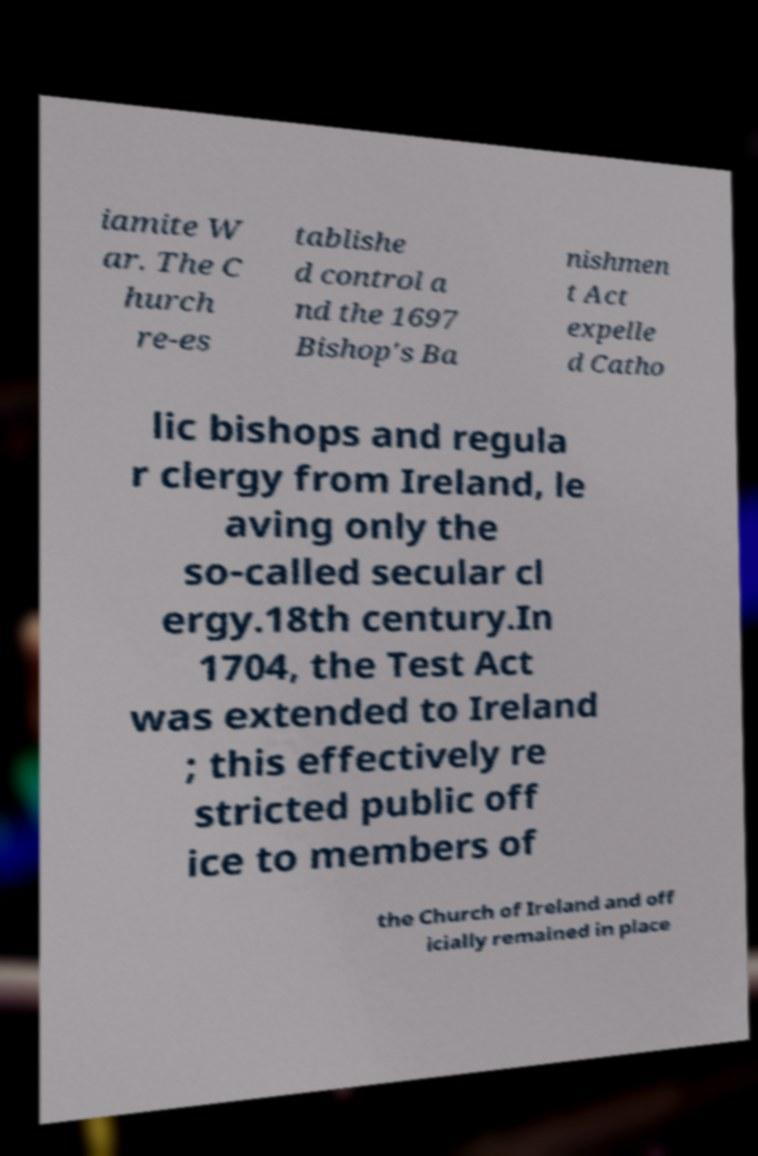Can you read and provide the text displayed in the image?This photo seems to have some interesting text. Can you extract and type it out for me? iamite W ar. The C hurch re-es tablishe d control a nd the 1697 Bishop's Ba nishmen t Act expelle d Catho lic bishops and regula r clergy from Ireland, le aving only the so-called secular cl ergy.18th century.In 1704, the Test Act was extended to Ireland ; this effectively re stricted public off ice to members of the Church of Ireland and off icially remained in place 